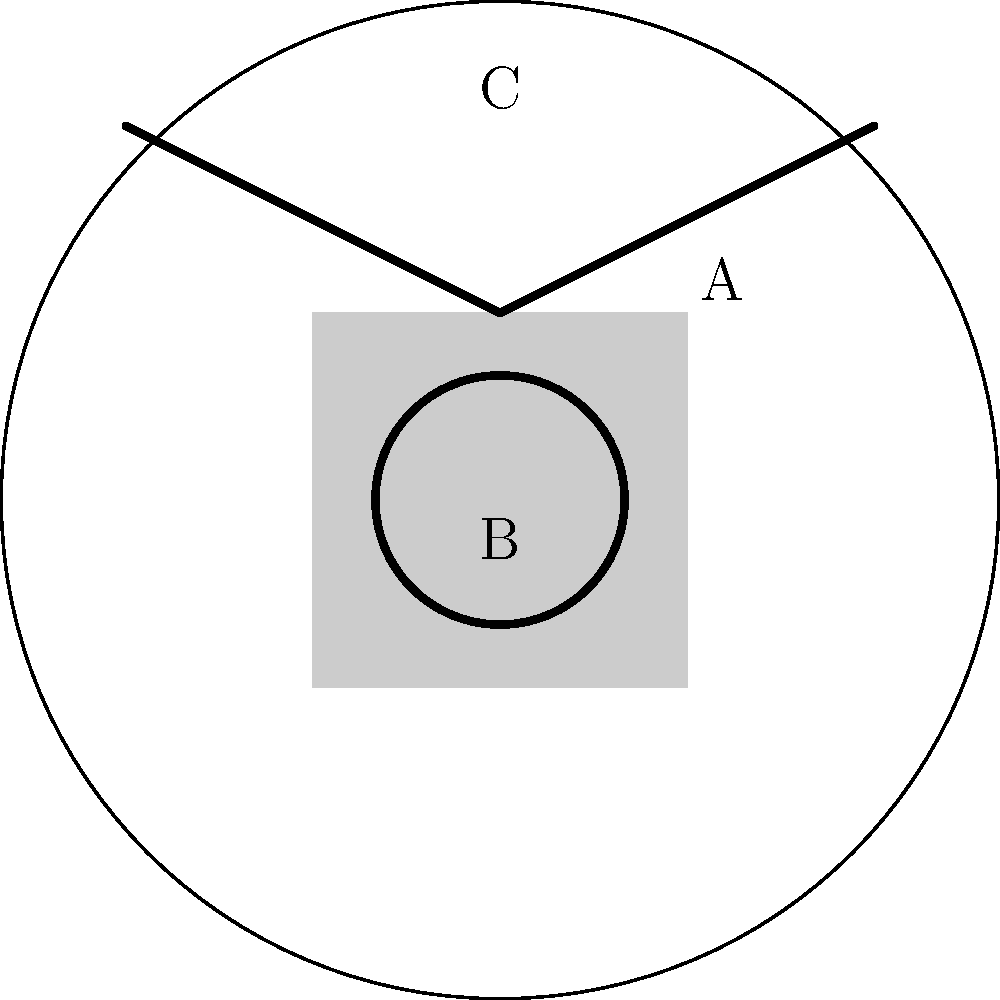Examine the pottery shard depicted above, which contains three distinct symbols labeled A, B, and C. Based on your knowledge of our ancient cultural traditions, which symbol is most likely associated with fertility and abundance? To interpret these symbols and determine which one is most likely associated with fertility and abundance, let's analyze each symbol step-by-step:

1. Symbol A: This is a square shape. In many ancient cultures, squares often represent stability, foundation, or the earth. While important, it's not typically associated with fertility or abundance.

2. Symbol B: This is a circle. Circles are universally recognized symbols of wholeness, unity, and the cycle of life. In many ancient traditions, including ours, the circle is often associated with the womb, the full moon, or the cycle of seasons. These connections make it a strong candidate for representing fertility and abundance.

3. Symbol C: This appears to be a triangular or mountain-like shape. In some cultures, triangles pointing upward can represent male energy or fire, while in others, they might symbolize mountains or aspiration. While important, it's not as commonly associated with fertility and abundance as the circle.

Given our cultural context and the common symbolism found in ancient pottery:

- The circle (Symbol B) is most strongly associated with fertility and abundance.
- It represents the cyclical nature of life, the womb, and the fullness of the moon, all of which are closely tied to concepts of fertility and abundance in our ancient traditions.
Answer: Symbol B (the circle) 